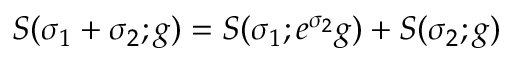<formula> <loc_0><loc_0><loc_500><loc_500>S ( \sigma _ { 1 } + \sigma _ { 2 } ; g ) = S ( \sigma _ { 1 } ; e ^ { \sigma _ { 2 } } g ) + S ( \sigma _ { 2 } ; g )</formula> 